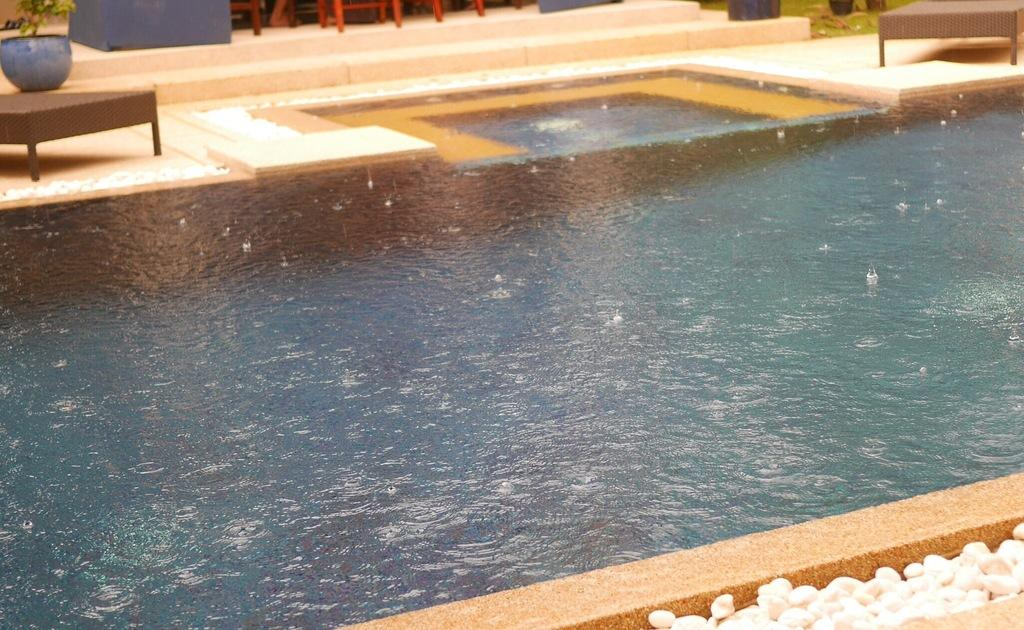What is the main feature in the center of the image? There is a swimming pool in the center of the image. What can be seen in the background of the image? There are tables and a flower pot in the background of the image. What is at the bottom of the image? There are stones at the bottom of the image. Where are the cows performing on the stage in the image? There are no cows or stage present in the image. 